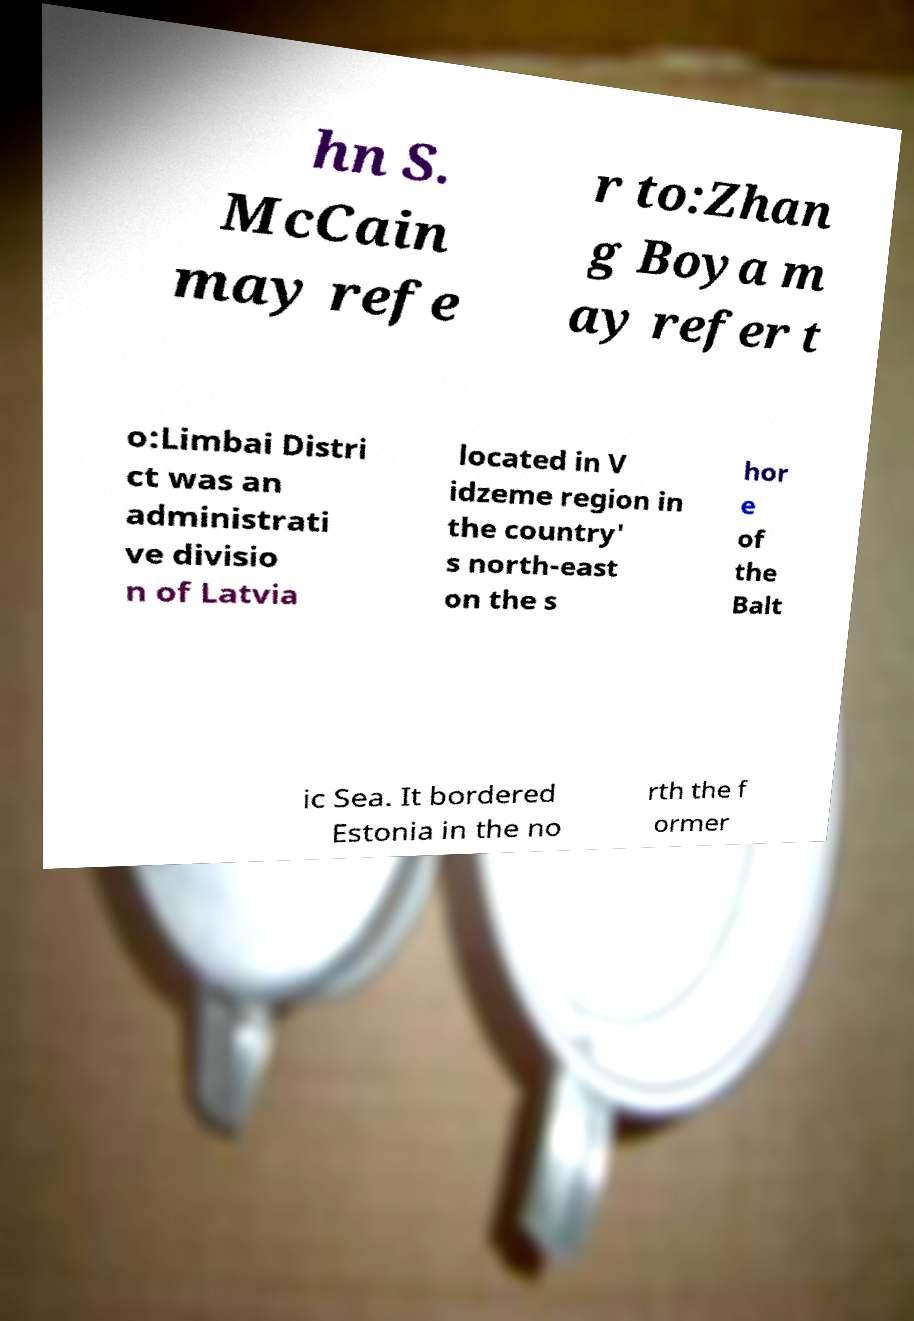There's text embedded in this image that I need extracted. Can you transcribe it verbatim? hn S. McCain may refe r to:Zhan g Boya m ay refer t o:Limbai Distri ct was an administrati ve divisio n of Latvia located in V idzeme region in the country' s north-east on the s hor e of the Balt ic Sea. It bordered Estonia in the no rth the f ormer 